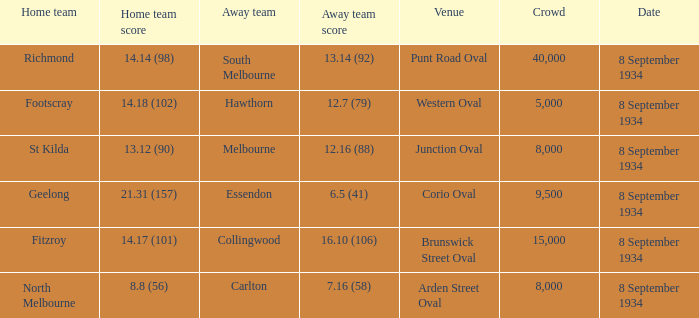When the Home team scored 14.14 (98), what did the Away Team score? 13.14 (92). 